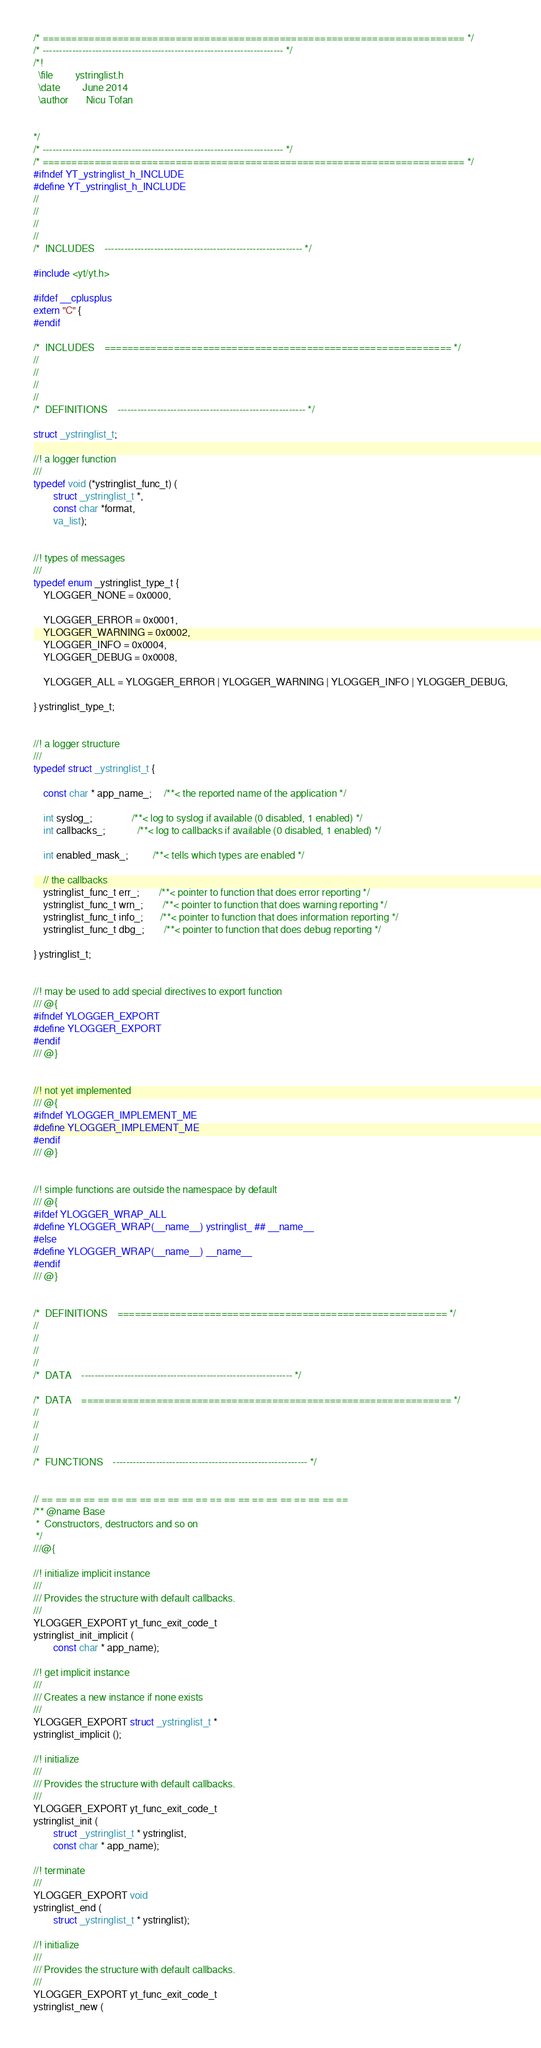Convert code to text. <code><loc_0><loc_0><loc_500><loc_500><_C_>/* ========================================================================= */
/* ------------------------------------------------------------------------- */
/*!
  \file			ystringlist.h
  \date			June 2014
  \author		Nicu Tofan


*/
/* ------------------------------------------------------------------------- */
/* ========================================================================= */
#ifndef YT_ystringlist_h_INCLUDE
#define YT_ystringlist_h_INCLUDE
//
//
//
//
/*  INCLUDES    ------------------------------------------------------------ */

#include <yt/yt.h>

#ifdef __cplusplus
extern "C" {
#endif

/*  INCLUDES    ============================================================ */
//
//
//
//
/*  DEFINITIONS    --------------------------------------------------------- */

struct _ystringlist_t;

//! a logger function
///
typedef void (*ystringlist_func_t) (
        struct _ystringlist_t *,
        const char *format,
        va_list);


//! types of messages
///
typedef enum _ystringlist_type_t {
    YLOGGER_NONE = 0x0000,

    YLOGGER_ERROR = 0x0001,
    YLOGGER_WARNING = 0x0002,
    YLOGGER_INFO = 0x0004,
    YLOGGER_DEBUG = 0x0008,

    YLOGGER_ALL = YLOGGER_ERROR | YLOGGER_WARNING | YLOGGER_INFO | YLOGGER_DEBUG,

} ystringlist_type_t;


//! a logger structure
///
typedef struct _ystringlist_t {

    const char * app_name_;     /**< the reported name of the application */

    int syslog_;                /**< log to syslog if available (0 disabled, 1 enabled) */
    int callbacks_;             /**< log to callbacks if available (0 disabled, 1 enabled) */

    int enabled_mask_;          /**< tells which types are enabled */

    // the callbacks
    ystringlist_func_t err_;        /**< pointer to function that does error reporting */
    ystringlist_func_t wrn_;        /**< pointer to function that does warning reporting */
    ystringlist_func_t info_;       /**< pointer to function that does information reporting */
    ystringlist_func_t dbg_;        /**< pointer to function that does debug reporting */

} ystringlist_t;


//! may be used to add special directives to export function
/// @{
#ifndef YLOGGER_EXPORT
#define YLOGGER_EXPORT
#endif
/// @}


//! not yet implemented
/// @{
#ifndef YLOGGER_IMPLEMENT_ME
#define YLOGGER_IMPLEMENT_ME
#endif
/// @}


//! simple functions are outside the namespace by default
/// @{
#ifdef YLOGGER_WRAP_ALL
#define YLOGGER_WRAP(__name__) ystringlist_ ## __name__
#else
#define YLOGGER_WRAP(__name__) __name__
#endif
/// @}


/*  DEFINITIONS    ========================================================= */
//
//
//
//
/*  DATA    ---------------------------------------------------------------- */

/*  DATA    ================================================================ */
//
//
//
//
/*  FUNCTIONS    ----------------------------------------------------------- */


// == == == == == == == == == == == == == == == == == == == == == ==
/** @name Base
 *  Constructors, destructors and so on
 */
///@{

//! initialize implicit instance
///
/// Provides the structure with default callbacks.
///
YLOGGER_EXPORT yt_func_exit_code_t
ystringlist_init_implicit (
        const char * app_name);

//! get implicit instance
///
/// Creates a new instance if none exists
///
YLOGGER_EXPORT struct _ystringlist_t *
ystringlist_implicit ();

//! initialize
///
/// Provides the structure with default callbacks.
///
YLOGGER_EXPORT yt_func_exit_code_t
ystringlist_init (
        struct _ystringlist_t * ystringlist,
        const char * app_name);

//! terminate
///
YLOGGER_EXPORT void
ystringlist_end (
        struct _ystringlist_t * ystringlist);

//! initialize
///
/// Provides the structure with default callbacks.
///
YLOGGER_EXPORT yt_func_exit_code_t
ystringlist_new (</code> 